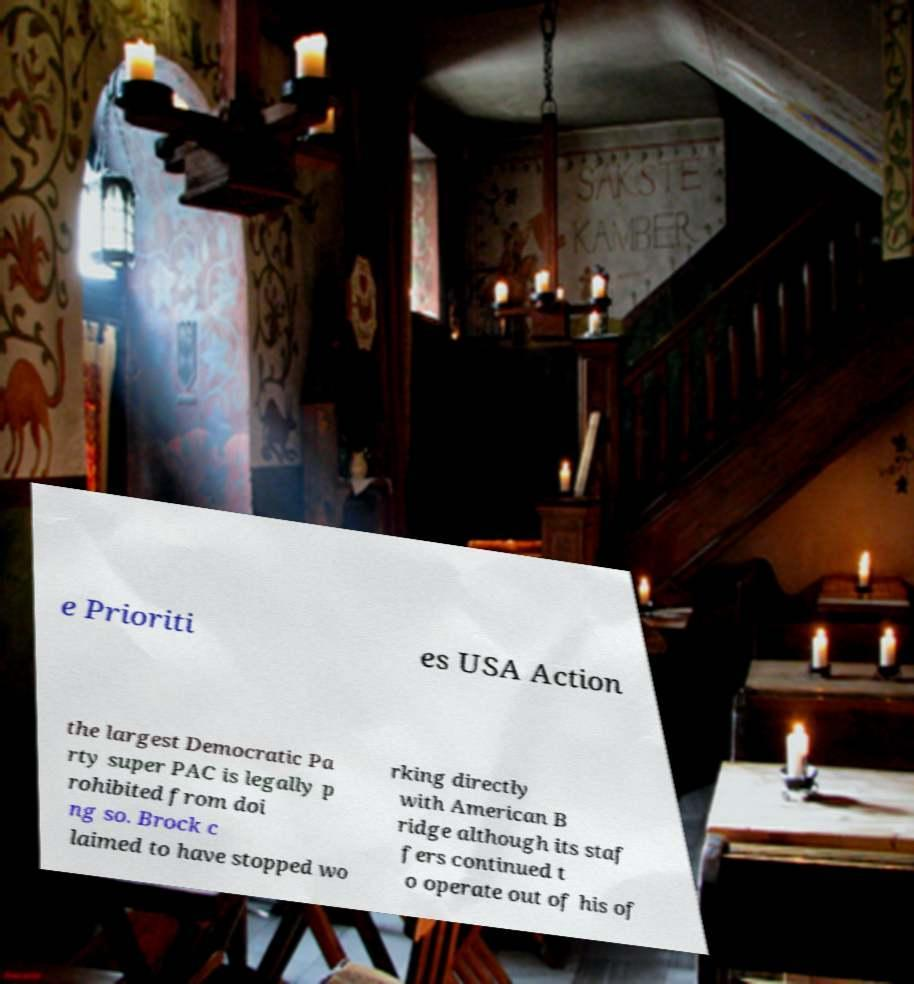Can you read and provide the text displayed in the image?This photo seems to have some interesting text. Can you extract and type it out for me? e Prioriti es USA Action the largest Democratic Pa rty super PAC is legally p rohibited from doi ng so. Brock c laimed to have stopped wo rking directly with American B ridge although its staf fers continued t o operate out of his of 